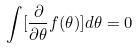<formula> <loc_0><loc_0><loc_500><loc_500>\int [ \frac { \partial } { \partial \theta } f ( \theta ) ] d \theta = 0</formula> 